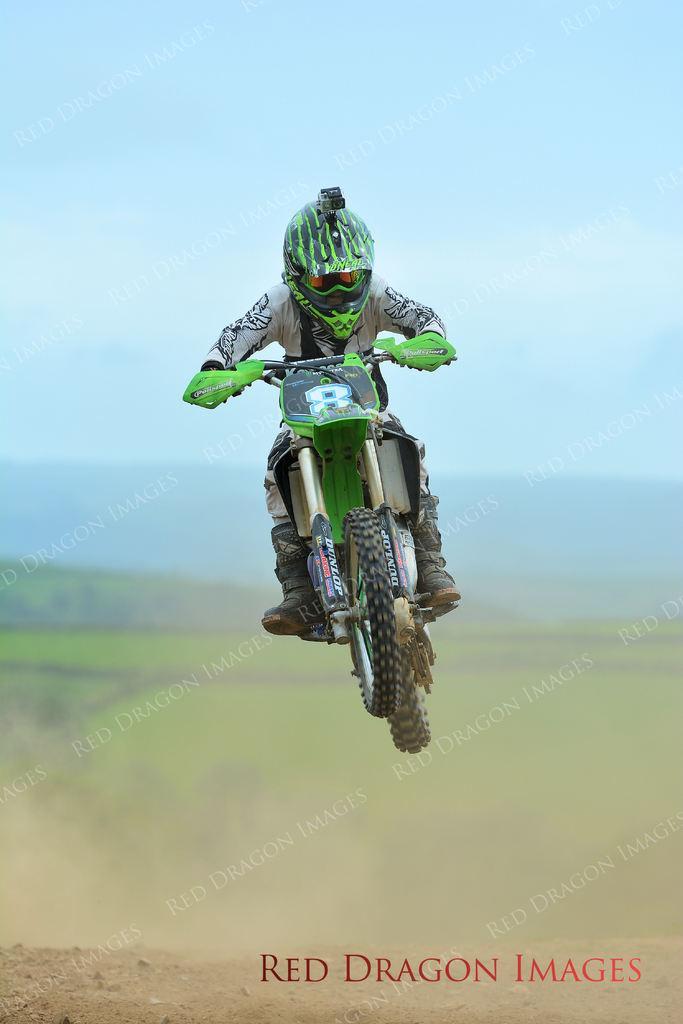In one or two sentences, can you explain what this image depicts? Here we can see a person riding a bike and he is in the air. There is a blur background and we can see sky. 